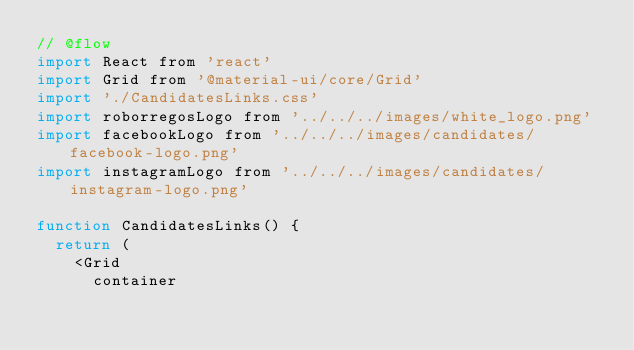Convert code to text. <code><loc_0><loc_0><loc_500><loc_500><_JavaScript_>// @flow
import React from 'react'
import Grid from '@material-ui/core/Grid'
import './CandidatesLinks.css'
import roborregosLogo from '../../../images/white_logo.png'
import facebookLogo from '../../../images/candidates/facebook-logo.png'
import instagramLogo from '../../../images/candidates/instagram-logo.png'

function CandidatesLinks() {
  return (
    <Grid
      container</code> 